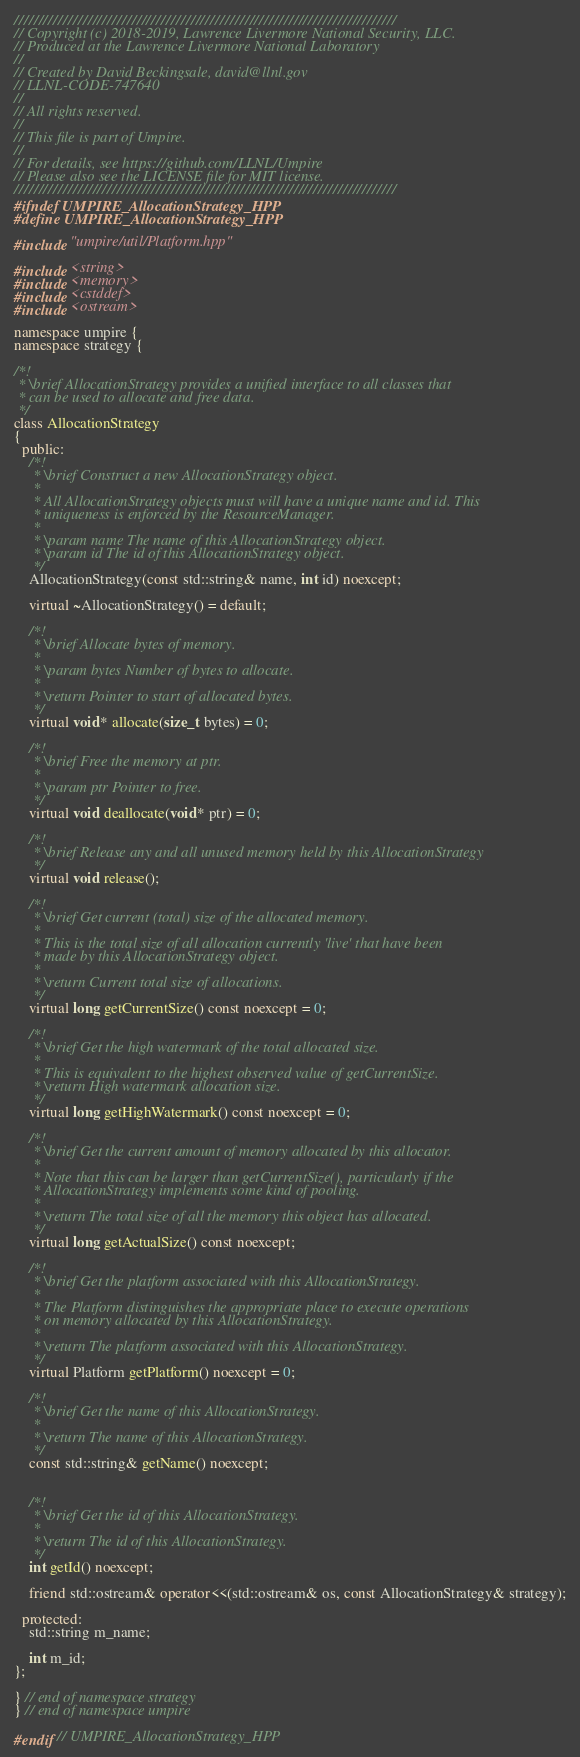<code> <loc_0><loc_0><loc_500><loc_500><_C++_>//////////////////////////////////////////////////////////////////////////////
// Copyright (c) 2018-2019, Lawrence Livermore National Security, LLC.
// Produced at the Lawrence Livermore National Laboratory
//
// Created by David Beckingsale, david@llnl.gov
// LLNL-CODE-747640
//
// All rights reserved.
//
// This file is part of Umpire.
//
// For details, see https://github.com/LLNL/Umpire
// Please also see the LICENSE file for MIT license.
//////////////////////////////////////////////////////////////////////////////
#ifndef UMPIRE_AllocationStrategy_HPP
#define UMPIRE_AllocationStrategy_HPP

#include "umpire/util/Platform.hpp"

#include <string>
#include <memory>
#include <cstddef>
#include <ostream>

namespace umpire {
namespace strategy {

/*!
 * \brief AllocationStrategy provides a unified interface to all classes that
 * can be used to allocate and free data.
 */
class AllocationStrategy 
{
  public:
    /*!
     * \brief Construct a new AllocationStrategy object.
     *
     * All AllocationStrategy objects must will have a unique name and id. This
     * uniqueness is enforced by the ResourceManager.
     *
     * \param name The name of this AllocationStrategy object.
     * \param id The id of this AllocationStrategy object.
     */
    AllocationStrategy(const std::string& name, int id) noexcept;

    virtual ~AllocationStrategy() = default;

    /*!
     * \brief Allocate bytes of memory.
     *
     * \param bytes Number of bytes to allocate.
     *
     * \return Pointer to start of allocated bytes.
     */
    virtual void* allocate(size_t bytes) = 0;

    /*!
     * \brief Free the memory at ptr.
     *
     * \param ptr Pointer to free.
     */
    virtual void deallocate(void* ptr) = 0;

    /*!
     * \brief Release any and all unused memory held by this AllocationStrategy
     */
    virtual void release();

    /*!
     * \brief Get current (total) size of the allocated memory.
     *
     * This is the total size of all allocation currently 'live' that have been
     * made by this AllocationStrategy object.
     *
     * \return Current total size of allocations.
     */
    virtual long getCurrentSize() const noexcept = 0;

    /*!
     * \brief Get the high watermark of the total allocated size.
     *
     * This is equivalent to the highest observed value of getCurrentSize.
     * \return High watermark allocation size.
     */
    virtual long getHighWatermark() const noexcept = 0;

    /*!
     * \brief Get the current amount of memory allocated by this allocator.
     *
     * Note that this can be larger than getCurrentSize(), particularly if the
     * AllocationStrategy implements some kind of pooling.
     *
     * \return The total size of all the memory this object has allocated.
     */
    virtual long getActualSize() const noexcept;

    /*!
     * \brief Get the platform associated with this AllocationStrategy.
     *
     * The Platform distinguishes the appropriate place to execute operations
     * on memory allocated by this AllocationStrategy.
     *
     * \return The platform associated with this AllocationStrategy.
     */
    virtual Platform getPlatform() noexcept = 0;

    /*!
     * \brief Get the name of this AllocationStrategy.
     *
     * \return The name of this AllocationStrategy.
     */
    const std::string& getName() noexcept;


    /*!
     * \brief Get the id of this AllocationStrategy.
     *
     * \return The id of this AllocationStrategy.
     */
    int getId() noexcept;

    friend std::ostream& operator<<(std::ostream& os, const AllocationStrategy& strategy);

  protected:
    std::string m_name;

    int m_id;
};

} // end of namespace strategy
} // end of namespace umpire

#endif // UMPIRE_AllocationStrategy_HPP
</code> 